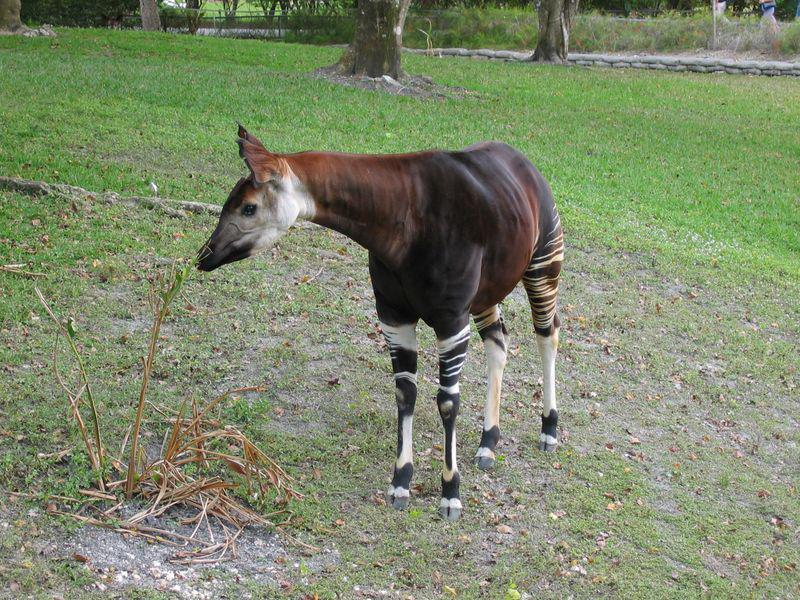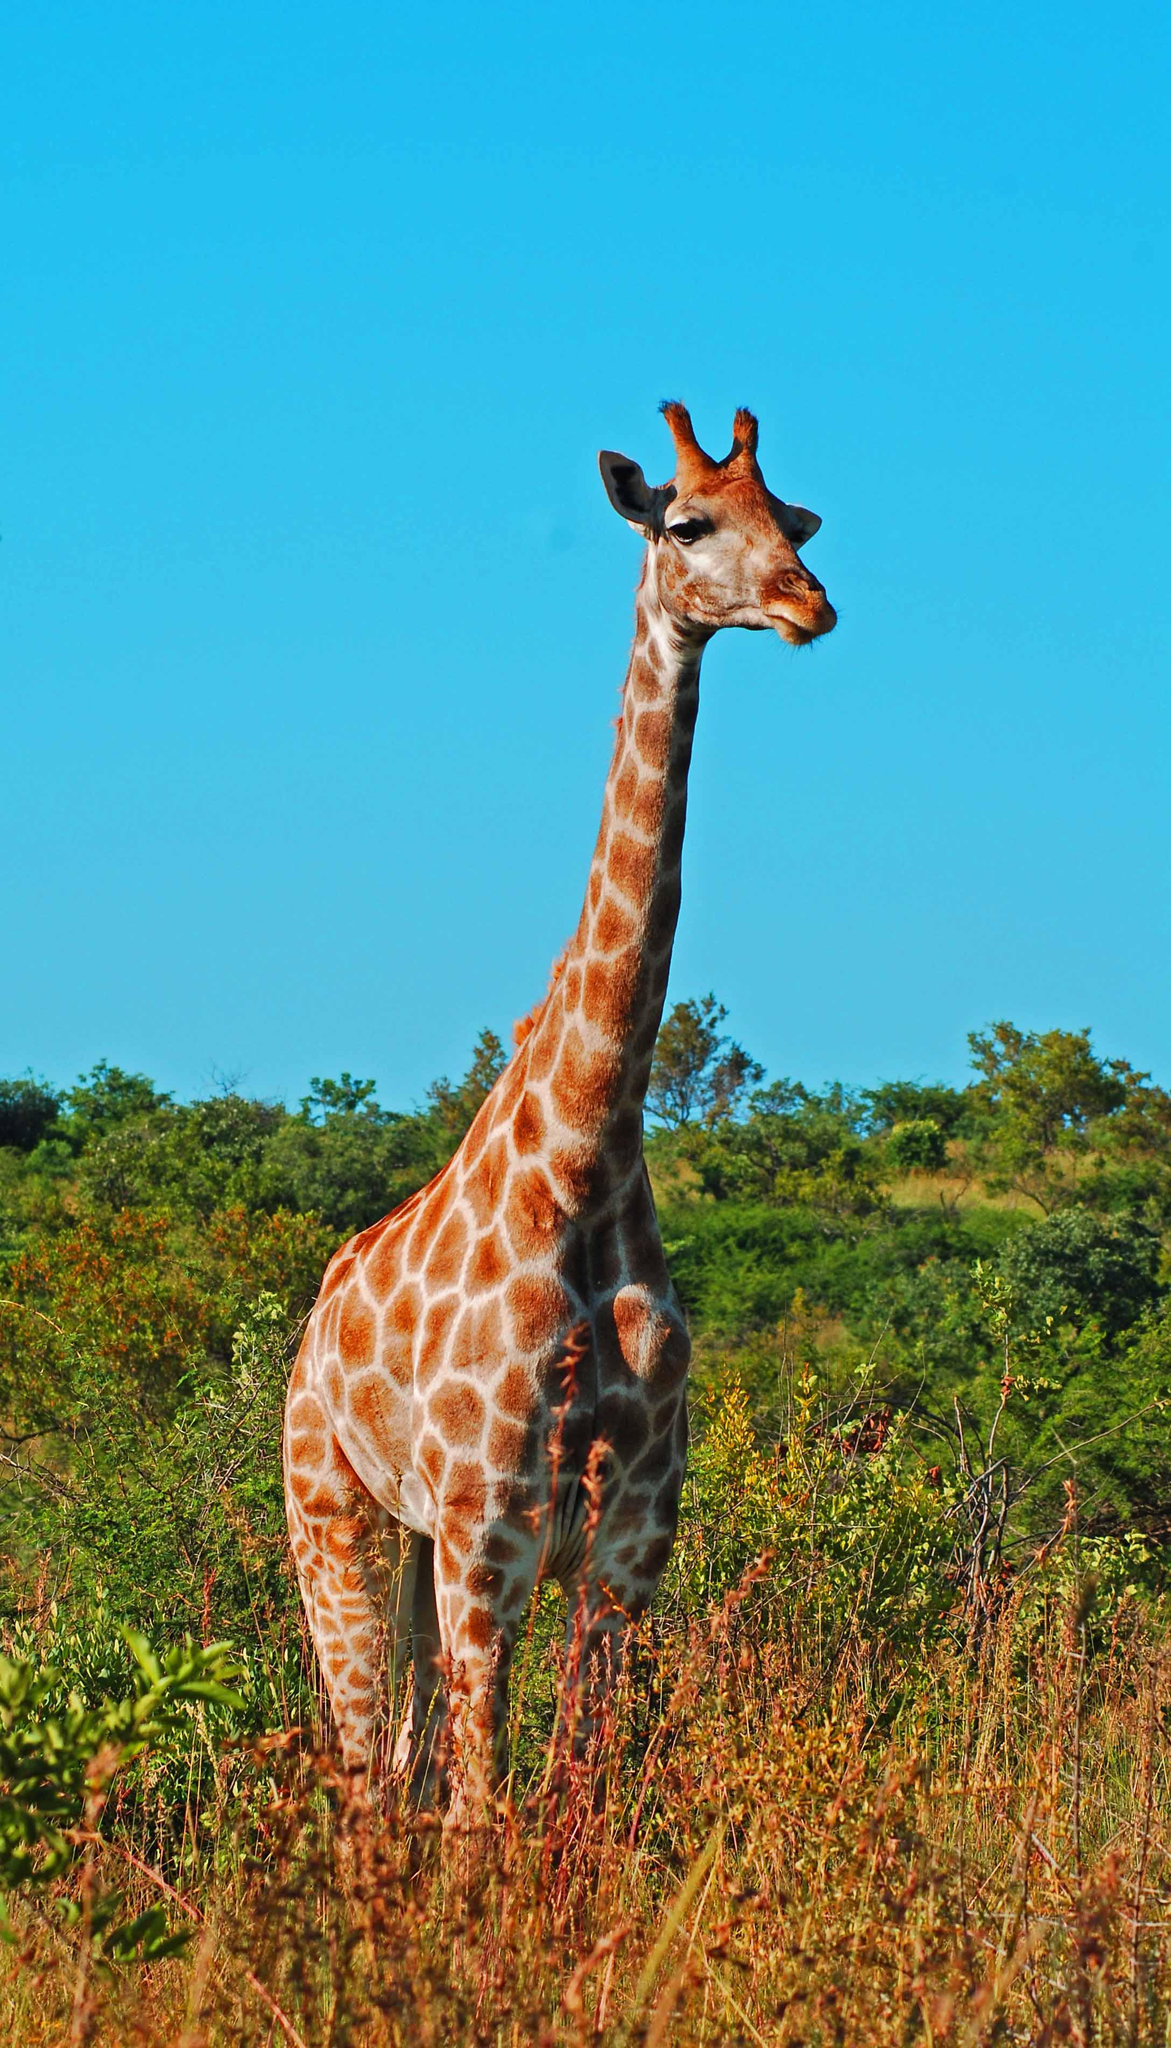The first image is the image on the left, the second image is the image on the right. Examine the images to the left and right. Is the description "Each image has one animal that has horns." accurate? Answer yes or no. No. 